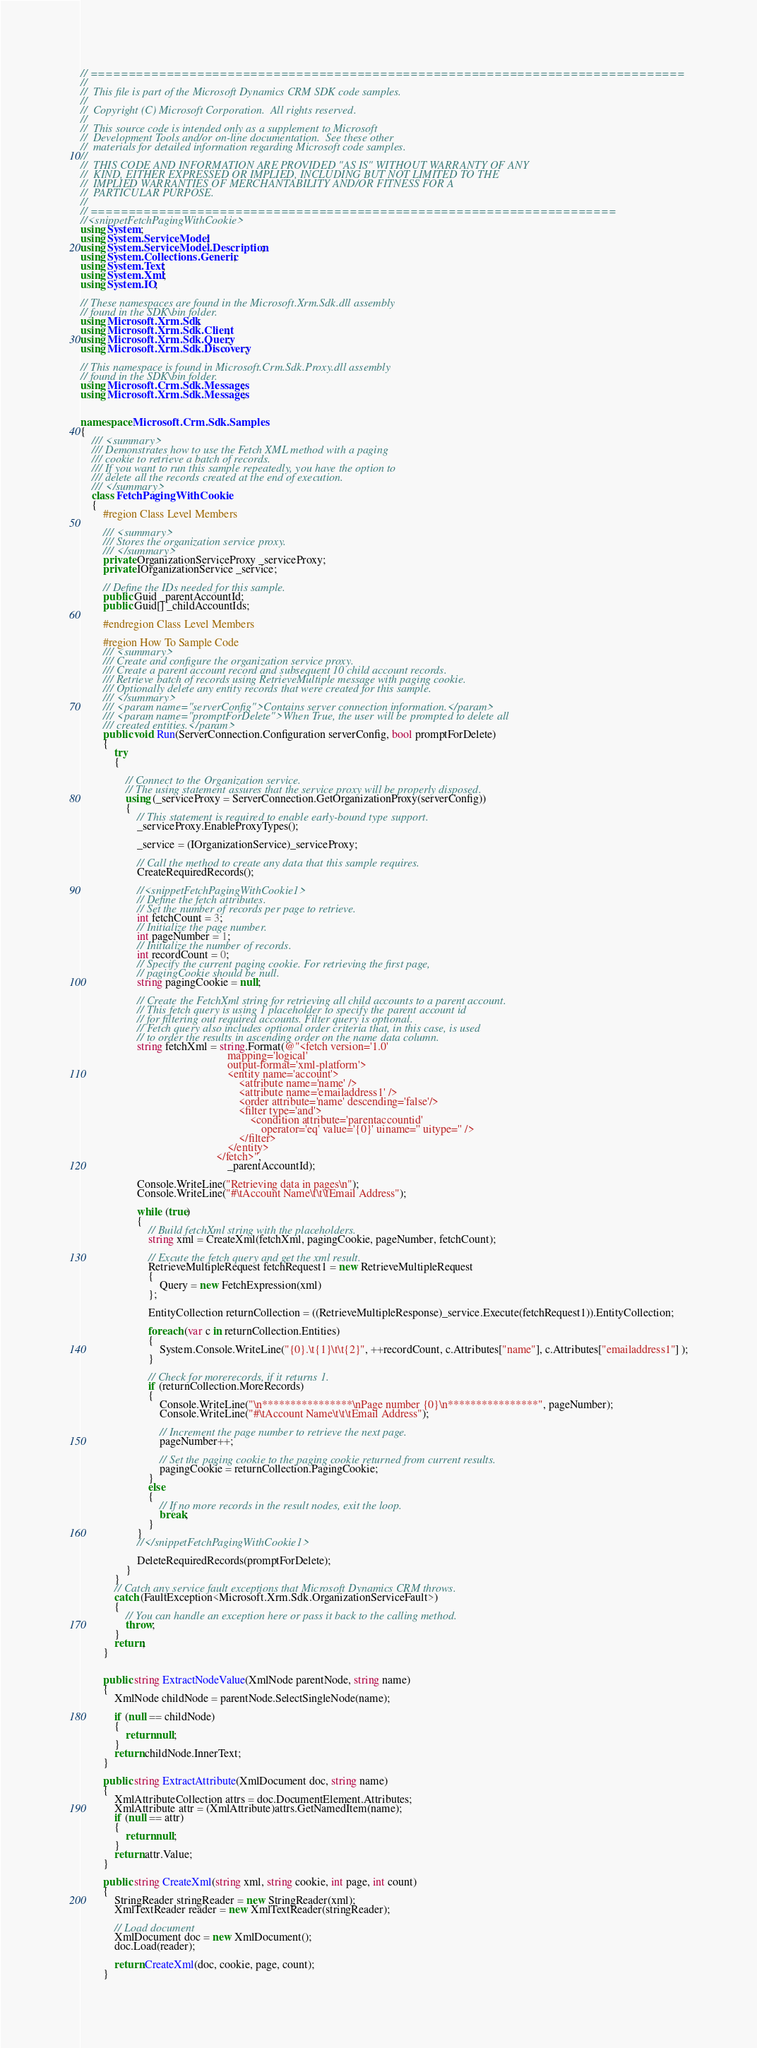Convert code to text. <code><loc_0><loc_0><loc_500><loc_500><_C#_>// ==============================================================================
//
//  This file is part of the Microsoft Dynamics CRM SDK code samples.
//
//  Copyright (C) Microsoft Corporation.  All rights reserved.
//
//  This source code is intended only as a supplement to Microsoft
//  Development Tools and/or on-line documentation.  See these other
//  materials for detailed information regarding Microsoft code samples.
//
//  THIS CODE AND INFORMATION ARE PROVIDED "AS IS" WITHOUT WARRANTY OF ANY
//  KIND, EITHER EXPRESSED OR IMPLIED, INCLUDING BUT NOT LIMITED TO THE
//  IMPLIED WARRANTIES OF MERCHANTABILITY AND/OR FITNESS FOR A
//  PARTICULAR PURPOSE.
//
// =====================================================================
//<snippetFetchPagingWithCookie>
using System;
using System.ServiceModel;
using System.ServiceModel.Description;
using System.Collections.Generic;
using System.Text;
using System.Xml;
using System.IO;

// These namespaces are found in the Microsoft.Xrm.Sdk.dll assembly
// found in the SDK\bin folder.
using Microsoft.Xrm.Sdk;
using Microsoft.Xrm.Sdk.Client;
using Microsoft.Xrm.Sdk.Query;
using Microsoft.Xrm.Sdk.Discovery;

// This namespace is found in Microsoft.Crm.Sdk.Proxy.dll assembly
// found in the SDK\bin folder.
using Microsoft.Crm.Sdk.Messages;
using Microsoft.Xrm.Sdk.Messages;


namespace Microsoft.Crm.Sdk.Samples
{
    /// <summary>
    /// Demonstrates how to use the Fetch XML method with a paging
    /// cookie to retrieve a batch of records.
    /// If you want to run this sample repeatedly, you have the option to 
    /// delete all the records created at the end of execution.
    /// </summary>
    class FetchPagingWithCookie
    {
        #region Class Level Members

        /// <summary>
        /// Stores the organization service proxy.
        /// </summary>
        private OrganizationServiceProxy _serviceProxy;
        private IOrganizationService _service;

        // Define the IDs needed for this sample.
        public Guid _parentAccountId;
        public Guid[] _childAccountIds;

        #endregion Class Level Members

        #region How To Sample Code
        /// <summary>
        /// Create and configure the organization service proxy.
        /// Create a parent account record and subsequent 10 child account records.
        /// Retrieve batch of records using RetrieveMultiple message with paging cookie.
        /// Optionally delete any entity records that were created for this sample.
        /// </summary>
        /// <param name="serverConfig">Contains server connection information.</param>
        /// <param name="promptForDelete">When True, the user will be prompted to delete all
        /// created entities.</param>
        public void Run(ServerConnection.Configuration serverConfig, bool promptForDelete)
        {
            try
            {

                // Connect to the Organization service. 
                // The using statement assures that the service proxy will be properly disposed.
                using (_serviceProxy = ServerConnection.GetOrganizationProxy(serverConfig))
                {
                    // This statement is required to enable early-bound type support.
                    _serviceProxy.EnableProxyTypes();

                    _service = (IOrganizationService)_serviceProxy;

                    // Call the method to create any data that this sample requires.
                    CreateRequiredRecords();

                    //<snippetFetchPagingWithCookie1>
                    // Define the fetch attributes.
                    // Set the number of records per page to retrieve.
                    int fetchCount = 3;
                    // Initialize the page number.
                    int pageNumber = 1;
                    // Initialize the number of records.
                    int recordCount = 0;
                    // Specify the current paging cookie. For retrieving the first page, 
                    // pagingCookie should be null.
                    string pagingCookie = null;

                    // Create the FetchXml string for retrieving all child accounts to a parent account.
                    // This fetch query is using 1 placeholder to specify the parent account id 
                    // for filtering out required accounts. Filter query is optional.
                    // Fetch query also includes optional order criteria that, in this case, is used 
                    // to order the results in ascending order on the name data column.
                    string fetchXml = string.Format(@"<fetch version='1.0' 
                                                    mapping='logical' 
                                                    output-format='xml-platform'>
                                                    <entity name='account'>
                                                        <attribute name='name' />
                                                        <attribute name='emailaddress1' />
                                                        <order attribute='name' descending='false'/>
                                                        <filter type='and'>
				                                            <condition attribute='parentaccountid' 
                                                                operator='eq' value='{0}' uiname='' uitype='' />
                                                        </filter>
                                                    </entity>
                                                </fetch>",
                                                    _parentAccountId);

                    Console.WriteLine("Retrieving data in pages\n"); 
                    Console.WriteLine("#\tAccount Name\t\t\tEmail Address");

                    while (true)
                    {
                        // Build fetchXml string with the placeholders.
                        string xml = CreateXml(fetchXml, pagingCookie, pageNumber, fetchCount);

                        // Excute the fetch query and get the xml result.
                        RetrieveMultipleRequest fetchRequest1 = new RetrieveMultipleRequest
                        {
                            Query = new FetchExpression(xml)
                        };

                        EntityCollection returnCollection = ((RetrieveMultipleResponse)_service.Execute(fetchRequest1)).EntityCollection;
                        
                        foreach (var c in returnCollection.Entities)
                        {
                            System.Console.WriteLine("{0}.\t{1}\t\t{2}", ++recordCount, c.Attributes["name"], c.Attributes["emailaddress1"] );
                        }                        
                        
                        // Check for morerecords, if it returns 1.
                        if (returnCollection.MoreRecords)
                        {
                            Console.WriteLine("\n****************\nPage number {0}\n****************", pageNumber);
                            Console.WriteLine("#\tAccount Name\t\t\tEmail Address");
                            
                            // Increment the page number to retrieve the next page.
                            pageNumber++;

                            // Set the paging cookie to the paging cookie returned from current results.                            
                            pagingCookie = returnCollection.PagingCookie;
                        }
                        else
                        {
                            // If no more records in the result nodes, exit the loop.
                            break;
                        }
                    }
                    //</snippetFetchPagingWithCookie1>                    

                    DeleteRequiredRecords(promptForDelete);
                }
            }
            // Catch any service fault exceptions that Microsoft Dynamics CRM throws.
            catch (FaultException<Microsoft.Xrm.Sdk.OrganizationServiceFault>)
            {
                // You can handle an exception here or pass it back to the calling method.
                throw;
            }
            return;
        }

        
        public string ExtractNodeValue(XmlNode parentNode, string name)
        {
            XmlNode childNode = parentNode.SelectSingleNode(name);

            if (null == childNode)
            {
                return null;
            }
            return childNode.InnerText;
        }

        public string ExtractAttribute(XmlDocument doc, string name)
        {
            XmlAttributeCollection attrs = doc.DocumentElement.Attributes;
            XmlAttribute attr = (XmlAttribute)attrs.GetNamedItem(name);
            if (null == attr)
            {
                return null;
            }
            return attr.Value;
        }

        public string CreateXml(string xml, string cookie, int page, int count)
        {
            StringReader stringReader = new StringReader(xml);
            XmlTextReader reader = new XmlTextReader(stringReader);

            // Load document
            XmlDocument doc = new XmlDocument();
            doc.Load(reader);

            return CreateXml(doc, cookie, page, count);
        }
</code> 